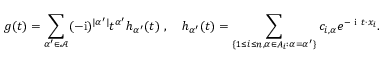<formula> <loc_0><loc_0><loc_500><loc_500>g ( t ) = \sum _ { \alpha ^ { \prime } \in \mathcal { A } } ( - i ) ^ { | \alpha ^ { \prime } | } t ^ { \alpha ^ { \prime } } h _ { \alpha ^ { \prime } } ( t ) \ , \quad h _ { \alpha ^ { \prime } } ( t ) = \sum _ { \{ 1 \leq i \leq n , \alpha \in A _ { i } \colon \alpha = \alpha ^ { \prime } \} } c _ { i , \alpha } e ^ { - i t \cdot x _ { i } } .</formula> 